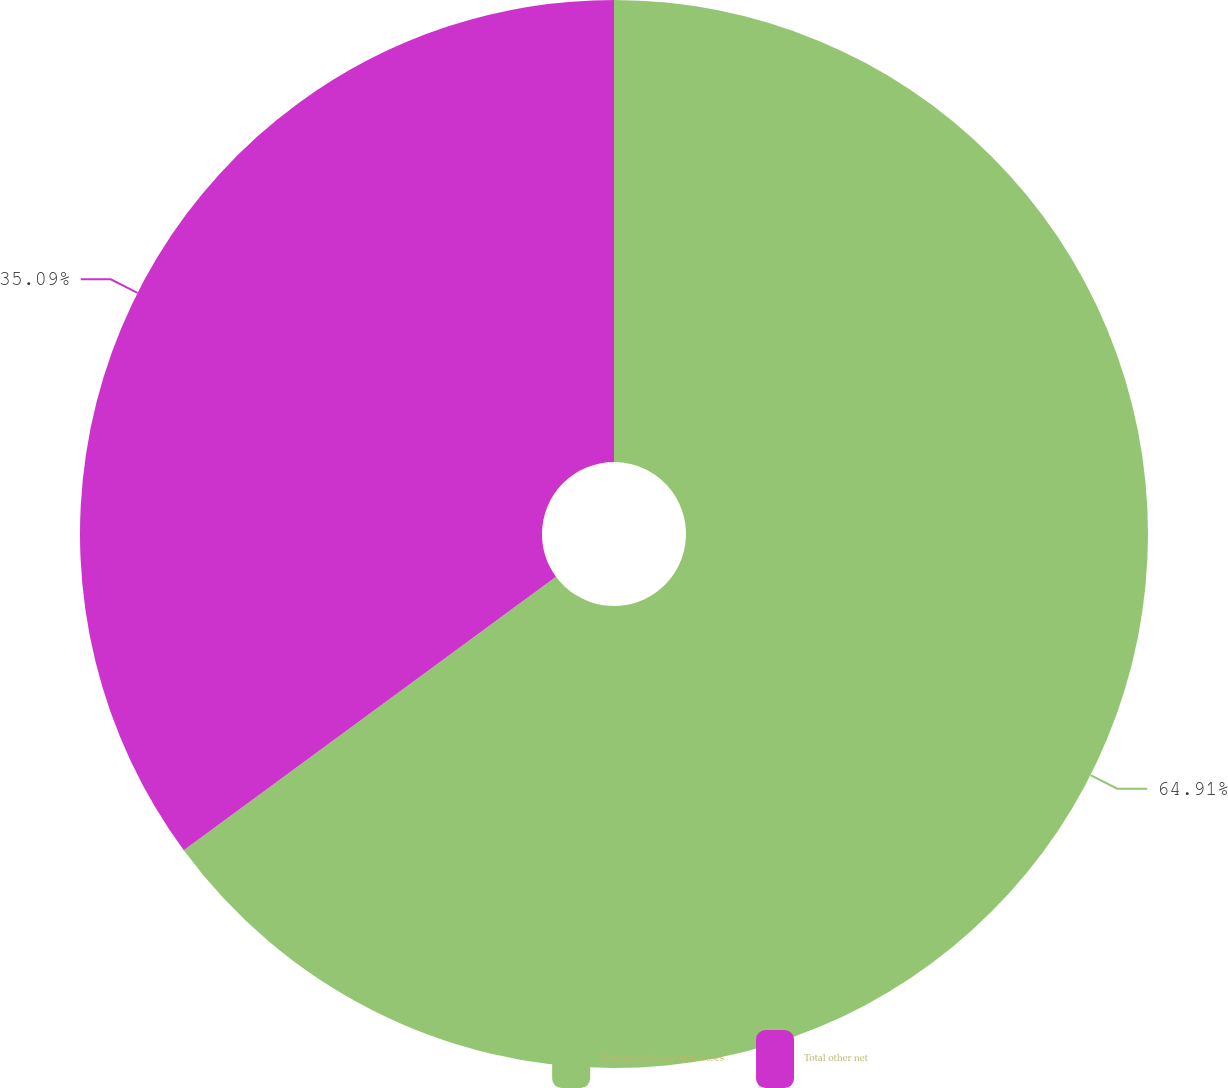Convert chart to OTSL. <chart><loc_0><loc_0><loc_500><loc_500><pie_chart><fcel>Foreign exchange rate losses<fcel>Total other net<nl><fcel>64.91%<fcel>35.09%<nl></chart> 